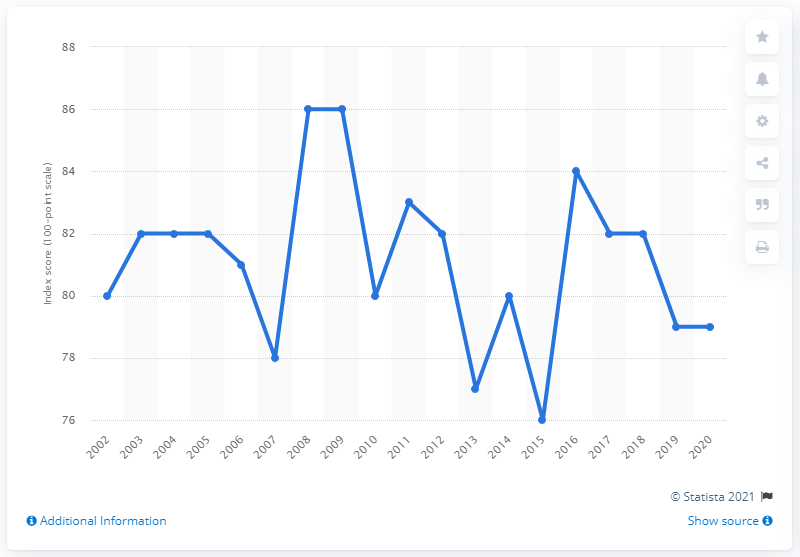Outline some significant characteristics in this image. According to the most recent customer satisfaction score provided by Google, the company received an overall rating of 79. 